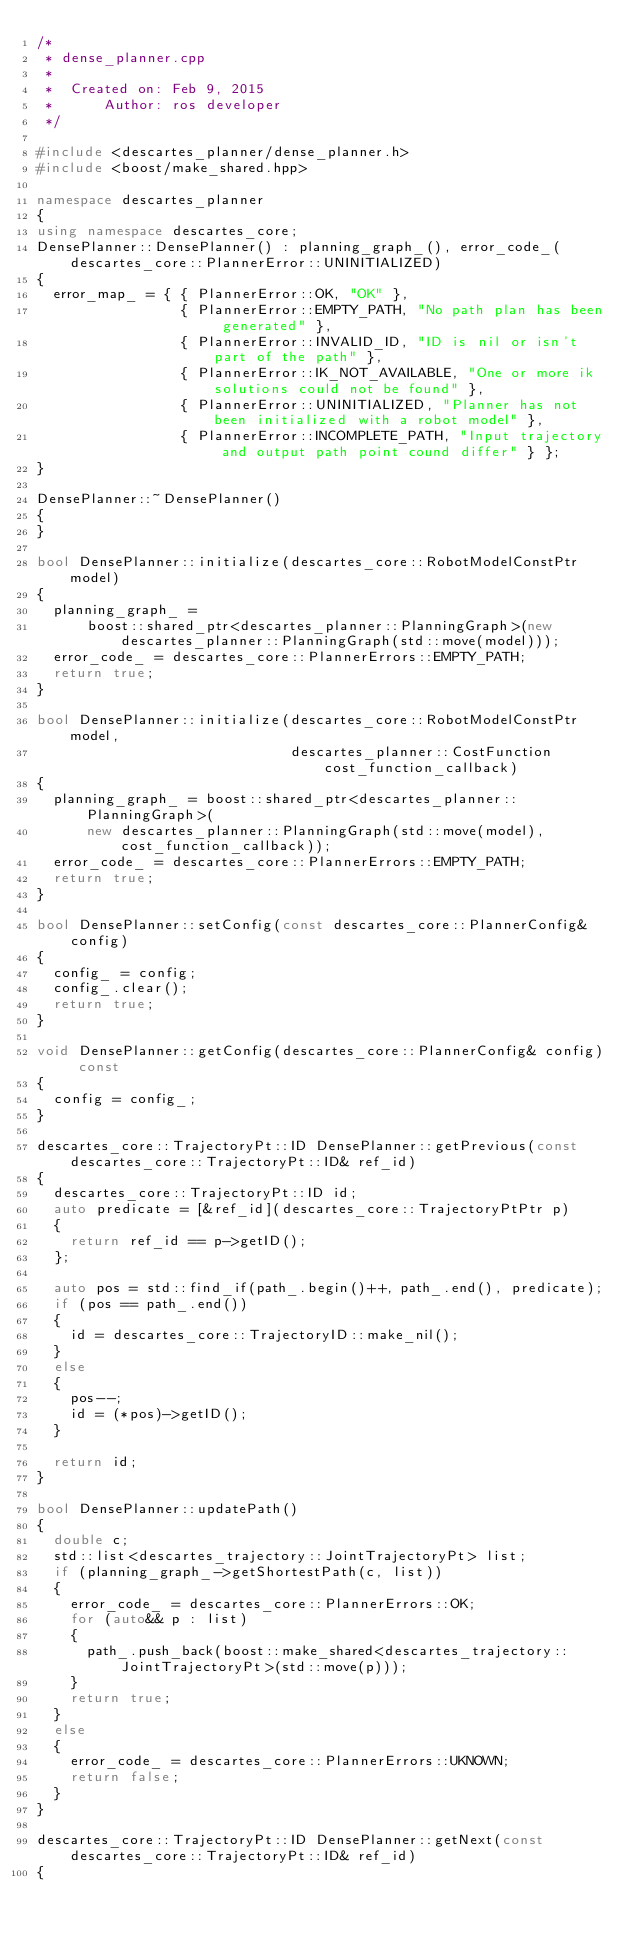<code> <loc_0><loc_0><loc_500><loc_500><_C++_>/*
 * dense_planner.cpp
 *
 *  Created on: Feb 9, 2015
 *      Author: ros developer
 */

#include <descartes_planner/dense_planner.h>
#include <boost/make_shared.hpp>

namespace descartes_planner
{
using namespace descartes_core;
DensePlanner::DensePlanner() : planning_graph_(), error_code_(descartes_core::PlannerError::UNINITIALIZED)
{
  error_map_ = { { PlannerError::OK, "OK" },
                 { PlannerError::EMPTY_PATH, "No path plan has been generated" },
                 { PlannerError::INVALID_ID, "ID is nil or isn't part of the path" },
                 { PlannerError::IK_NOT_AVAILABLE, "One or more ik solutions could not be found" },
                 { PlannerError::UNINITIALIZED, "Planner has not been initialized with a robot model" },
                 { PlannerError::INCOMPLETE_PATH, "Input trajectory and output path point cound differ" } };
}

DensePlanner::~DensePlanner()
{
}

bool DensePlanner::initialize(descartes_core::RobotModelConstPtr model)
{
  planning_graph_ =
      boost::shared_ptr<descartes_planner::PlanningGraph>(new descartes_planner::PlanningGraph(std::move(model)));
  error_code_ = descartes_core::PlannerErrors::EMPTY_PATH;
  return true;
}

bool DensePlanner::initialize(descartes_core::RobotModelConstPtr model,
                              descartes_planner::CostFunction cost_function_callback)
{
  planning_graph_ = boost::shared_ptr<descartes_planner::PlanningGraph>(
      new descartes_planner::PlanningGraph(std::move(model), cost_function_callback));
  error_code_ = descartes_core::PlannerErrors::EMPTY_PATH;
  return true;
}

bool DensePlanner::setConfig(const descartes_core::PlannerConfig& config)
{
  config_ = config;
  config_.clear();
  return true;
}

void DensePlanner::getConfig(descartes_core::PlannerConfig& config) const
{
  config = config_;
}

descartes_core::TrajectoryPt::ID DensePlanner::getPrevious(const descartes_core::TrajectoryPt::ID& ref_id)
{
  descartes_core::TrajectoryPt::ID id;
  auto predicate = [&ref_id](descartes_core::TrajectoryPtPtr p)
  {
    return ref_id == p->getID();
  };

  auto pos = std::find_if(path_.begin()++, path_.end(), predicate);
  if (pos == path_.end())
  {
    id = descartes_core::TrajectoryID::make_nil();
  }
  else
  {
    pos--;
    id = (*pos)->getID();
  }

  return id;
}

bool DensePlanner::updatePath()
{
  double c;
  std::list<descartes_trajectory::JointTrajectoryPt> list;
  if (planning_graph_->getShortestPath(c, list))
  {
    error_code_ = descartes_core::PlannerErrors::OK;
    for (auto&& p : list)
    {
      path_.push_back(boost::make_shared<descartes_trajectory::JointTrajectoryPt>(std::move(p)));
    }
    return true;
  }
  else
  {
    error_code_ = descartes_core::PlannerErrors::UKNOWN;
    return false;
  }
}

descartes_core::TrajectoryPt::ID DensePlanner::getNext(const descartes_core::TrajectoryPt::ID& ref_id)
{</code> 